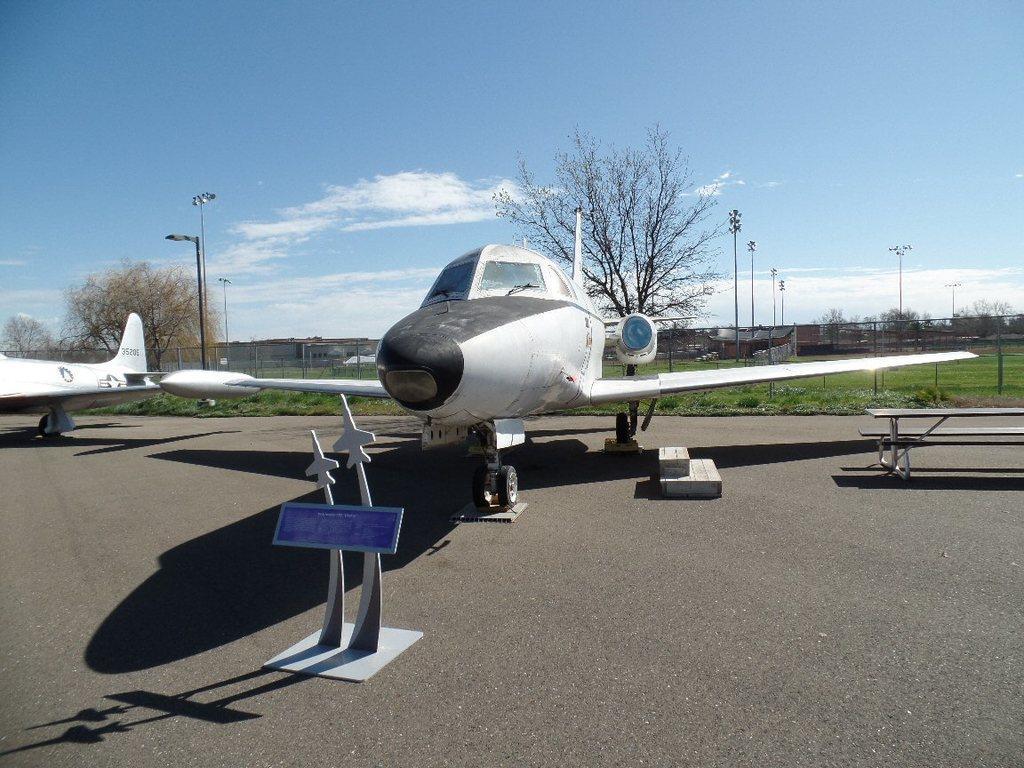How would you summarize this image in a sentence or two? In this picture I can see there is an aeroplane in white color in the middle of an image. There are trees at the back side and there is the sky at the top. 